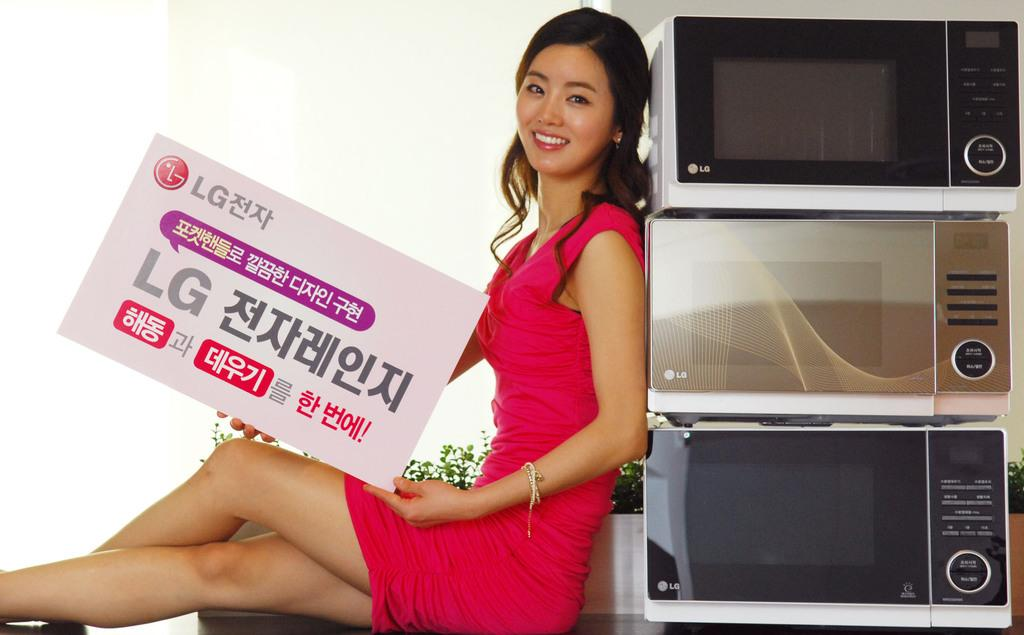<image>
Describe the image concisely. An attractive spokesmodel holds an oversized LG business card in her lap. 